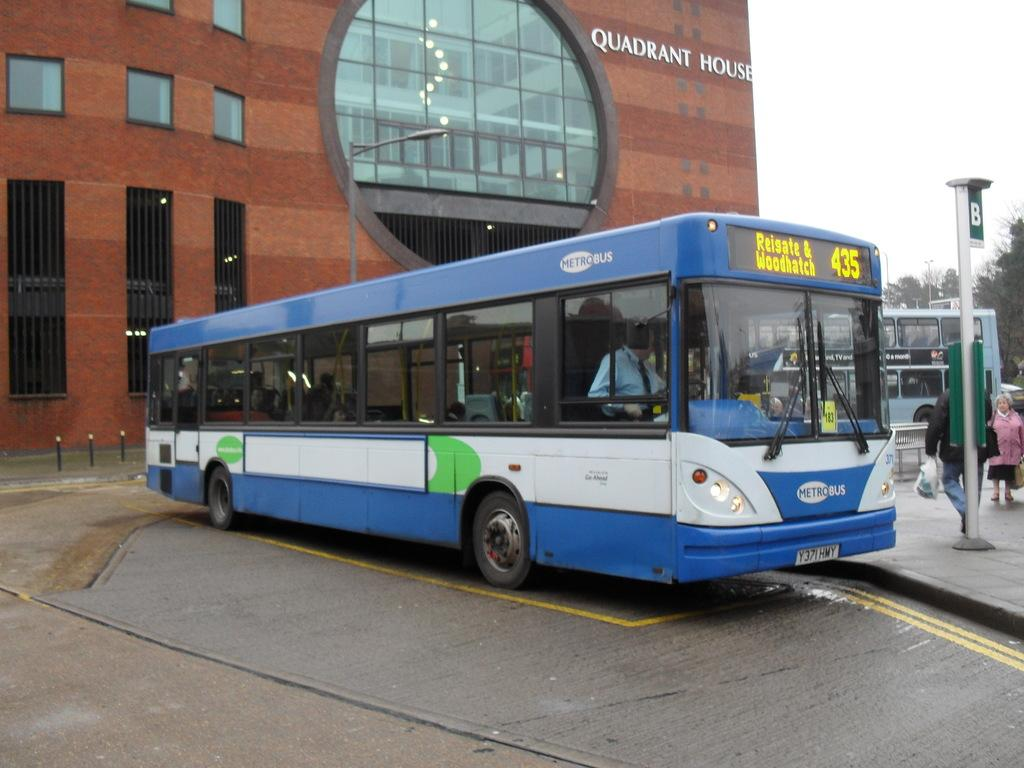What is the main subject in the center of the image? There are buses on the road in the center of the image. What are the people doing on the right side of the image? There are people walking on the right side of the image. What can be seen in the image besides the buses and people? There is a board visible in the image. What is visible in the background of the image? There is a building, a pole, trees, and the sky visible in the background of the image. Can you tell me how many snails are crawling on the board in the image? There are no snails present in the image; the board is the only object mentioned in the facts. What type of insurance is being advertised on the board in the image? There is no information about insurance or any advertisement on the board in the image. 